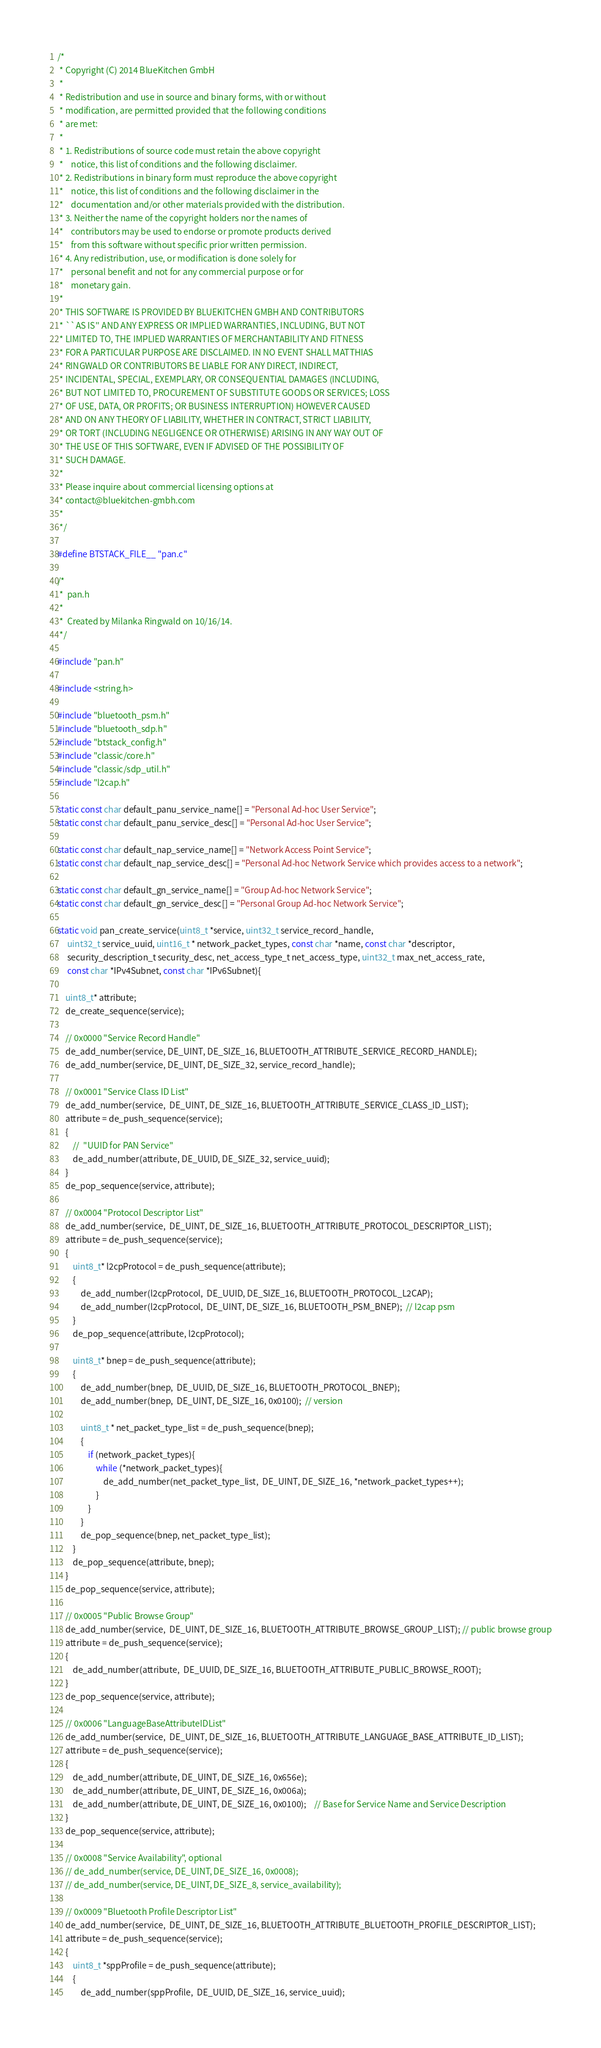Convert code to text. <code><loc_0><loc_0><loc_500><loc_500><_C_>/*
 * Copyright (C) 2014 BlueKitchen GmbH
 *
 * Redistribution and use in source and binary forms, with or without
 * modification, are permitted provided that the following conditions
 * are met:
 *
 * 1. Redistributions of source code must retain the above copyright
 *    notice, this list of conditions and the following disclaimer.
 * 2. Redistributions in binary form must reproduce the above copyright
 *    notice, this list of conditions and the following disclaimer in the
 *    documentation and/or other materials provided with the distribution.
 * 3. Neither the name of the copyright holders nor the names of
 *    contributors may be used to endorse or promote products derived
 *    from this software without specific prior written permission.
 * 4. Any redistribution, use, or modification is done solely for
 *    personal benefit and not for any commercial purpose or for
 *    monetary gain.
 *
 * THIS SOFTWARE IS PROVIDED BY BLUEKITCHEN GMBH AND CONTRIBUTORS
 * ``AS IS'' AND ANY EXPRESS OR IMPLIED WARRANTIES, INCLUDING, BUT NOT
 * LIMITED TO, THE IMPLIED WARRANTIES OF MERCHANTABILITY AND FITNESS
 * FOR A PARTICULAR PURPOSE ARE DISCLAIMED. IN NO EVENT SHALL MATTHIAS
 * RINGWALD OR CONTRIBUTORS BE LIABLE FOR ANY DIRECT, INDIRECT,
 * INCIDENTAL, SPECIAL, EXEMPLARY, OR CONSEQUENTIAL DAMAGES (INCLUDING,
 * BUT NOT LIMITED TO, PROCUREMENT OF SUBSTITUTE GOODS OR SERVICES; LOSS
 * OF USE, DATA, OR PROFITS; OR BUSINESS INTERRUPTION) HOWEVER CAUSED
 * AND ON ANY THEORY OF LIABILITY, WHETHER IN CONTRACT, STRICT LIABILITY,
 * OR TORT (INCLUDING NEGLIGENCE OR OTHERWISE) ARISING IN ANY WAY OUT OF
 * THE USE OF THIS SOFTWARE, EVEN IF ADVISED OF THE POSSIBILITY OF
 * SUCH DAMAGE.
 *
 * Please inquire about commercial licensing options at 
 * contact@bluekitchen-gmbh.com
 *
 */

#define BTSTACK_FILE__ "pan.c"

/*
 *  pan.h
 *
 *  Created by Milanka Ringwald on 10/16/14.
 */

#include "pan.h"

#include <string.h>

#include "bluetooth_psm.h"
#include "bluetooth_sdp.h"
#include "btstack_config.h"
#include "classic/core.h"
#include "classic/sdp_util.h"
#include "l2cap.h"

static const char default_panu_service_name[] = "Personal Ad-hoc User Service";
static const char default_panu_service_desc[] = "Personal Ad-hoc User Service";

static const char default_nap_service_name[] = "Network Access Point Service";
static const char default_nap_service_desc[] = "Personal Ad-hoc Network Service which provides access to a network";

static const char default_gn_service_name[] = "Group Ad-hoc Network Service";
static const char default_gn_service_desc[] = "Personal Group Ad-hoc Network Service";

static void pan_create_service(uint8_t *service, uint32_t service_record_handle,
	 uint32_t service_uuid, uint16_t * network_packet_types, const char *name, const char *descriptor,
	 security_description_t security_desc, net_access_type_t net_access_type, uint32_t max_net_access_rate,
	 const char *IPv4Subnet, const char *IPv6Subnet){

	uint8_t* attribute;
	de_create_sequence(service);

	// 0x0000 "Service Record Handle"
	de_add_number(service, DE_UINT, DE_SIZE_16, BLUETOOTH_ATTRIBUTE_SERVICE_RECORD_HANDLE);
	de_add_number(service, DE_UINT, DE_SIZE_32, service_record_handle);

	// 0x0001 "Service Class ID List"
	de_add_number(service,  DE_UINT, DE_SIZE_16, BLUETOOTH_ATTRIBUTE_SERVICE_CLASS_ID_LIST);
	attribute = de_push_sequence(service);
	{
		//  "UUID for PAN Service"
		de_add_number(attribute, DE_UUID, DE_SIZE_32, service_uuid);
	}
	de_pop_sequence(service, attribute);

	// 0x0004 "Protocol Descriptor List"
	de_add_number(service,  DE_UINT, DE_SIZE_16, BLUETOOTH_ATTRIBUTE_PROTOCOL_DESCRIPTOR_LIST);
	attribute = de_push_sequence(service);
	{
		uint8_t* l2cpProtocol = de_push_sequence(attribute);
		{
			de_add_number(l2cpProtocol,  DE_UUID, DE_SIZE_16, BLUETOOTH_PROTOCOL_L2CAP);
			de_add_number(l2cpProtocol,  DE_UINT, DE_SIZE_16, BLUETOOTH_PSM_BNEP);  // l2cap psm
		}
		de_pop_sequence(attribute, l2cpProtocol);
		
		uint8_t* bnep = de_push_sequence(attribute);
		{
			de_add_number(bnep,  DE_UUID, DE_SIZE_16, BLUETOOTH_PROTOCOL_BNEP);
			de_add_number(bnep,  DE_UINT, DE_SIZE_16, 0x0100);  // version

			uint8_t * net_packet_type_list = de_push_sequence(bnep);
			{		
				if (network_packet_types){
					while (*network_packet_types){
						de_add_number(net_packet_type_list,  DE_UINT, DE_SIZE_16, *network_packet_types++);
					}
				}
			}
			de_pop_sequence(bnep, net_packet_type_list);
		}
		de_pop_sequence(attribute, bnep);
	}
	de_pop_sequence(service, attribute);

	// 0x0005 "Public Browse Group"
	de_add_number(service,  DE_UINT, DE_SIZE_16, BLUETOOTH_ATTRIBUTE_BROWSE_GROUP_LIST); // public browse group
	attribute = de_push_sequence(service);
	{
		de_add_number(attribute,  DE_UUID, DE_SIZE_16, BLUETOOTH_ATTRIBUTE_PUBLIC_BROWSE_ROOT);
	}
	de_pop_sequence(service, attribute);

	// 0x0006 "LanguageBaseAttributeIDList"
	de_add_number(service,  DE_UINT, DE_SIZE_16, BLUETOOTH_ATTRIBUTE_LANGUAGE_BASE_ATTRIBUTE_ID_LIST);
	attribute = de_push_sequence(service);
	{
		de_add_number(attribute, DE_UINT, DE_SIZE_16, 0x656e);
		de_add_number(attribute, DE_UINT, DE_SIZE_16, 0x006a);
		de_add_number(attribute, DE_UINT, DE_SIZE_16, 0x0100);	// Base for Service Name and Service Description
	}
	de_pop_sequence(service, attribute);

	// 0x0008 "Service Availability", optional
	// de_add_number(service, DE_UINT, DE_SIZE_16, 0x0008);
	// de_add_number(service, DE_UINT, DE_SIZE_8, service_availability);

	// 0x0009 "Bluetooth Profile Descriptor List"
	de_add_number(service,  DE_UINT, DE_SIZE_16, BLUETOOTH_ATTRIBUTE_BLUETOOTH_PROFILE_DESCRIPTOR_LIST);
	attribute = de_push_sequence(service);
	{
		uint8_t *sppProfile = de_push_sequence(attribute);
		{
			de_add_number(sppProfile,  DE_UUID, DE_SIZE_16, service_uuid); </code> 